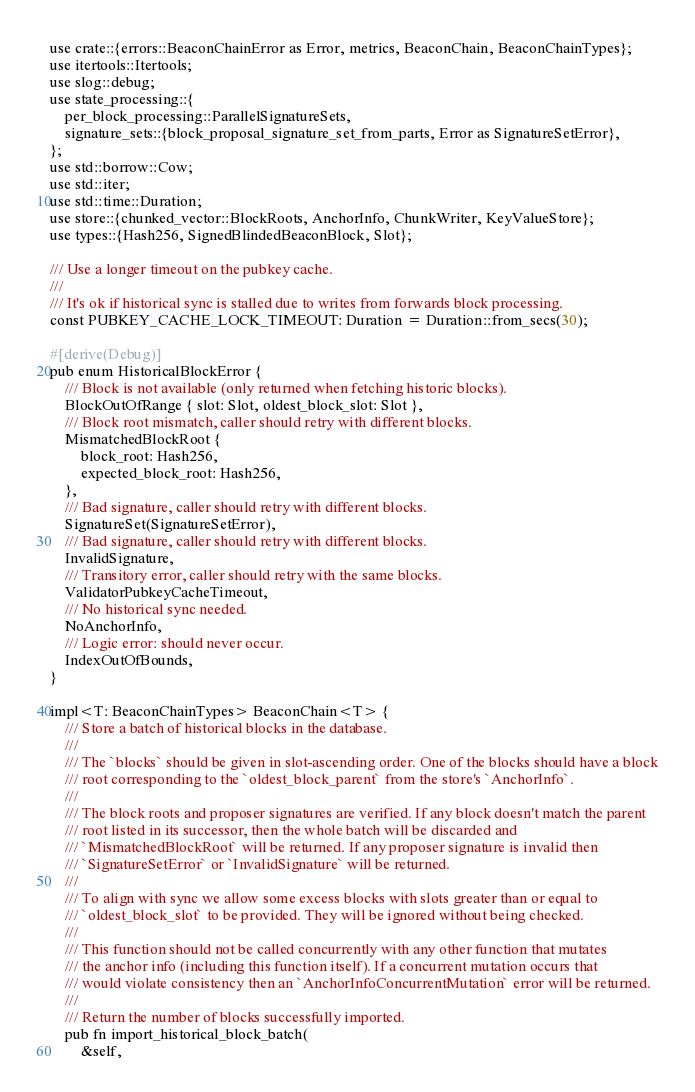Convert code to text. <code><loc_0><loc_0><loc_500><loc_500><_Rust_>use crate::{errors::BeaconChainError as Error, metrics, BeaconChain, BeaconChainTypes};
use itertools::Itertools;
use slog::debug;
use state_processing::{
    per_block_processing::ParallelSignatureSets,
    signature_sets::{block_proposal_signature_set_from_parts, Error as SignatureSetError},
};
use std::borrow::Cow;
use std::iter;
use std::time::Duration;
use store::{chunked_vector::BlockRoots, AnchorInfo, ChunkWriter, KeyValueStore};
use types::{Hash256, SignedBlindedBeaconBlock, Slot};

/// Use a longer timeout on the pubkey cache.
///
/// It's ok if historical sync is stalled due to writes from forwards block processing.
const PUBKEY_CACHE_LOCK_TIMEOUT: Duration = Duration::from_secs(30);

#[derive(Debug)]
pub enum HistoricalBlockError {
    /// Block is not available (only returned when fetching historic blocks).
    BlockOutOfRange { slot: Slot, oldest_block_slot: Slot },
    /// Block root mismatch, caller should retry with different blocks.
    MismatchedBlockRoot {
        block_root: Hash256,
        expected_block_root: Hash256,
    },
    /// Bad signature, caller should retry with different blocks.
    SignatureSet(SignatureSetError),
    /// Bad signature, caller should retry with different blocks.
    InvalidSignature,
    /// Transitory error, caller should retry with the same blocks.
    ValidatorPubkeyCacheTimeout,
    /// No historical sync needed.
    NoAnchorInfo,
    /// Logic error: should never occur.
    IndexOutOfBounds,
}

impl<T: BeaconChainTypes> BeaconChain<T> {
    /// Store a batch of historical blocks in the database.
    ///
    /// The `blocks` should be given in slot-ascending order. One of the blocks should have a block
    /// root corresponding to the `oldest_block_parent` from the store's `AnchorInfo`.
    ///
    /// The block roots and proposer signatures are verified. If any block doesn't match the parent
    /// root listed in its successor, then the whole batch will be discarded and
    /// `MismatchedBlockRoot` will be returned. If any proposer signature is invalid then
    /// `SignatureSetError` or `InvalidSignature` will be returned.
    ///
    /// To align with sync we allow some excess blocks with slots greater than or equal to
    /// `oldest_block_slot` to be provided. They will be ignored without being checked.
    ///
    /// This function should not be called concurrently with any other function that mutates
    /// the anchor info (including this function itself). If a concurrent mutation occurs that
    /// would violate consistency then an `AnchorInfoConcurrentMutation` error will be returned.
    ///
    /// Return the number of blocks successfully imported.
    pub fn import_historical_block_batch(
        &self,</code> 